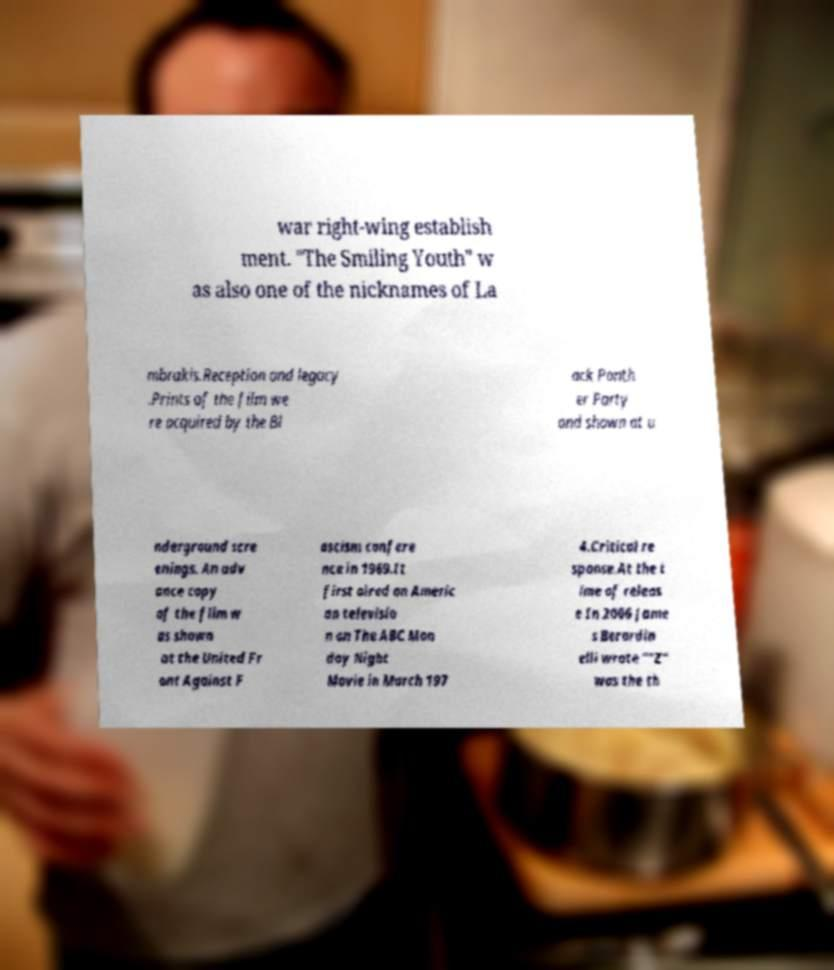Can you read and provide the text displayed in the image?This photo seems to have some interesting text. Can you extract and type it out for me? war right-wing establish ment. "The Smiling Youth" w as also one of the nicknames of La mbrakis.Reception and legacy .Prints of the film we re acquired by the Bl ack Panth er Party and shown at u nderground scre enings. An adv ance copy of the film w as shown at the United Fr ont Against F ascism confere nce in 1969.It first aired on Americ an televisio n on The ABC Mon day Night Movie in March 197 4.Critical re sponse.At the t ime of releas e In 2006 Jame s Berardin elli wrote ""Z" was the th 